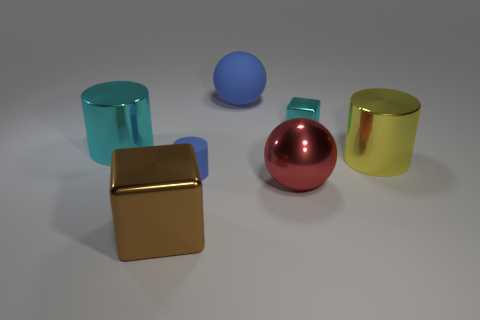Add 1 large metallic objects. How many objects exist? 8 Subtract all small cylinders. How many cylinders are left? 2 Subtract 1 spheres. How many spheres are left? 1 Subtract all balls. How many objects are left? 5 Subtract all cyan cylinders. How many cylinders are left? 2 Add 5 yellow objects. How many yellow objects exist? 6 Subtract 0 cyan spheres. How many objects are left? 7 Subtract all gray cylinders. Subtract all blue cubes. How many cylinders are left? 3 Subtract all small blue rubber cylinders. Subtract all rubber objects. How many objects are left? 4 Add 5 tiny blocks. How many tiny blocks are left? 6 